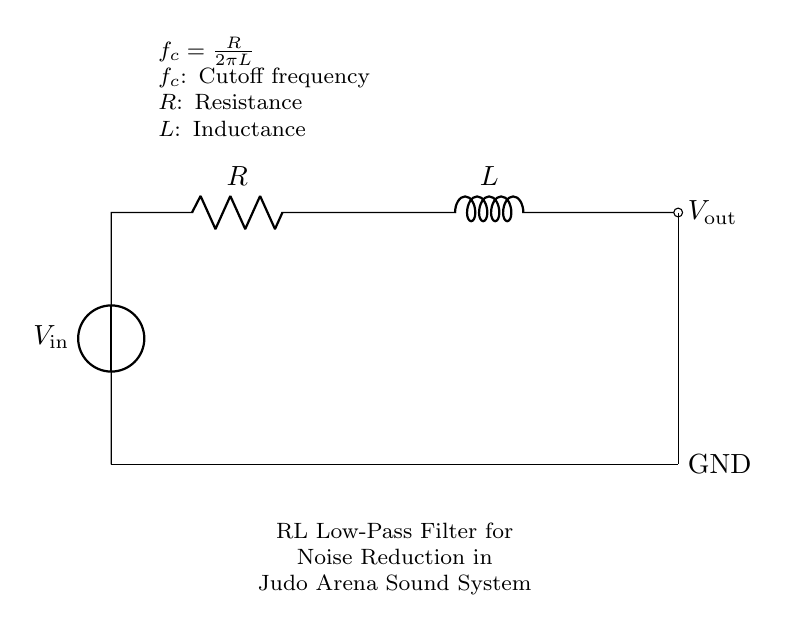What does the circuit primarily consist of? The circuit primarily consists of a voltage source, a resistor, and an inductor, which are all connected in series.
Answer: voltage source, resistor, inductor What is the purpose of this circuit? The purpose of the circuit is to act as an RL low-pass filter, which reduces noise in an audio system, particularly in arena sound systems during events.
Answer: noise reduction What is the output voltage connected to? The output voltage is connected to ground at the bottom of the schematic, indicating that the output is referenced to ground potential.
Answer: ground What is the cutoff frequency formula shown in the diagram? The cutoff frequency formula shown in the diagram is `f_c = R / (2πL)`, which indicates how the frequency limits are affected by resistance and inductance.
Answer: f_c = R / 2πL If resistance increases, what happens to the cutoff frequency? If resistance increases, the cutoff frequency decreases, following the inverse relationship in the cutoff frequency formula, meaning less high-frequency noise is allowed through.
Answer: decreases What connection type does the inductor use in this circuit? The inductor uses a series connection type, indicated by the direct line connecting it to the resistor before output, which means the current flows through both components in sequence.
Answer: series What does "f_c" stand for? "f_c" stands for cutoff frequency, which is the point in the circuit where the output voltage drops significantly, allowing only lower frequencies to pass through.
Answer: cutoff frequency 